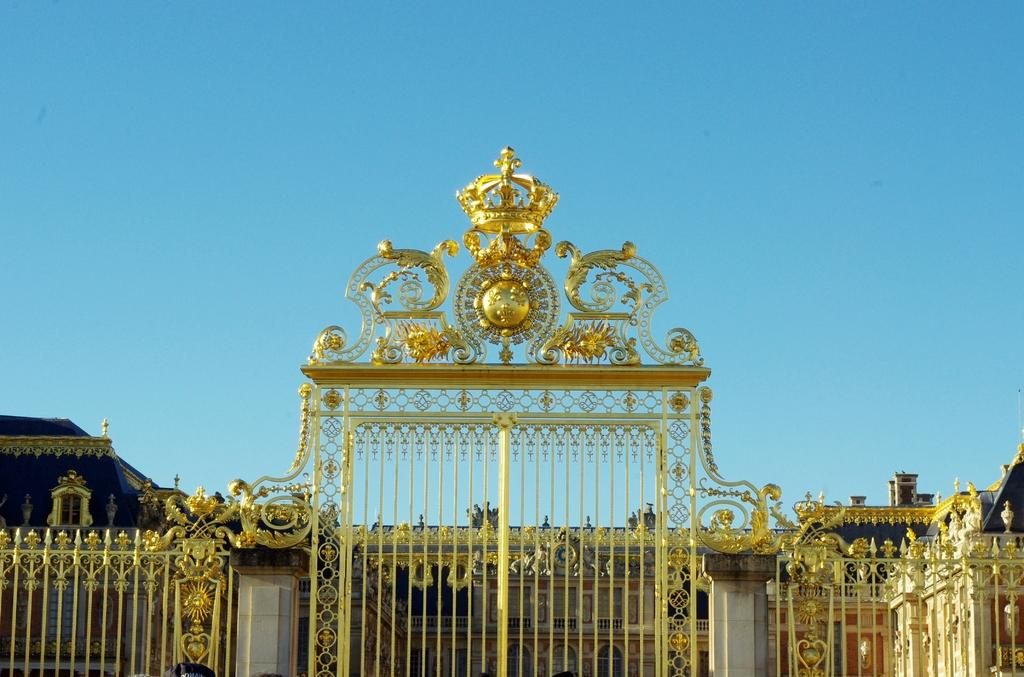What is located at the front of the image? There is a gate in the front of the image. What can be seen in the background of the image? There is a building in the background of the image. What is visible at the top of the image? The sky is visible at the top of the image. What architectural feature is present in the image? There is a pillar in the image. What type of drum is being played in the image? There is no drum present in the image. What religious symbol can be seen in the image? There is no religious symbol present in the image. 